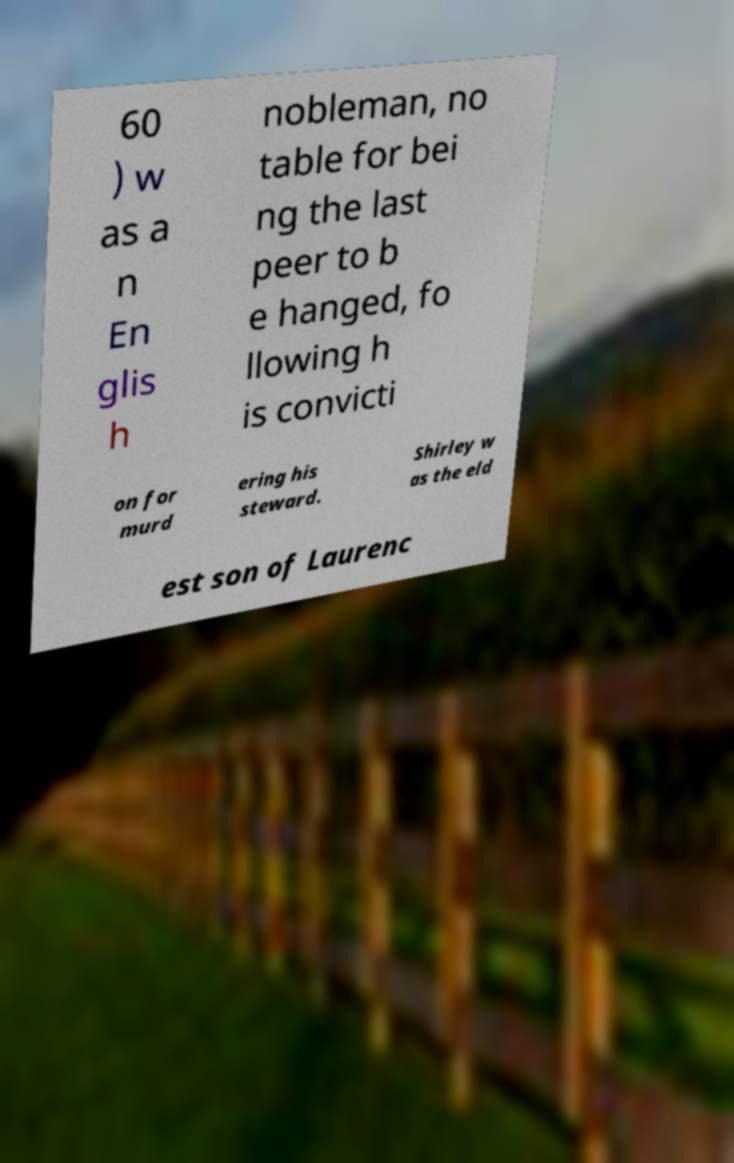Could you extract and type out the text from this image? 60 ) w as a n En glis h nobleman, no table for bei ng the last peer to b e hanged, fo llowing h is convicti on for murd ering his steward. Shirley w as the eld est son of Laurenc 